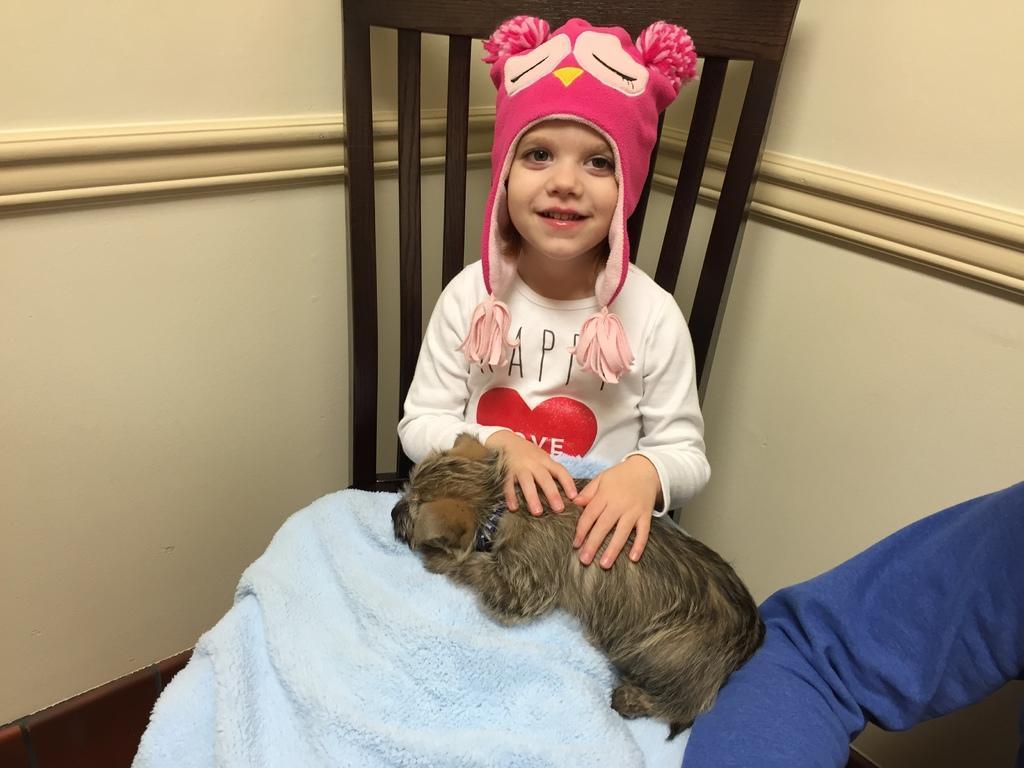In one or two sentences, can you explain what this image depicts? In this image there is a girl sitting on the chair and there is a dog on her lap, beside the girl we can see the hand of a person. In the background there is a wall. 